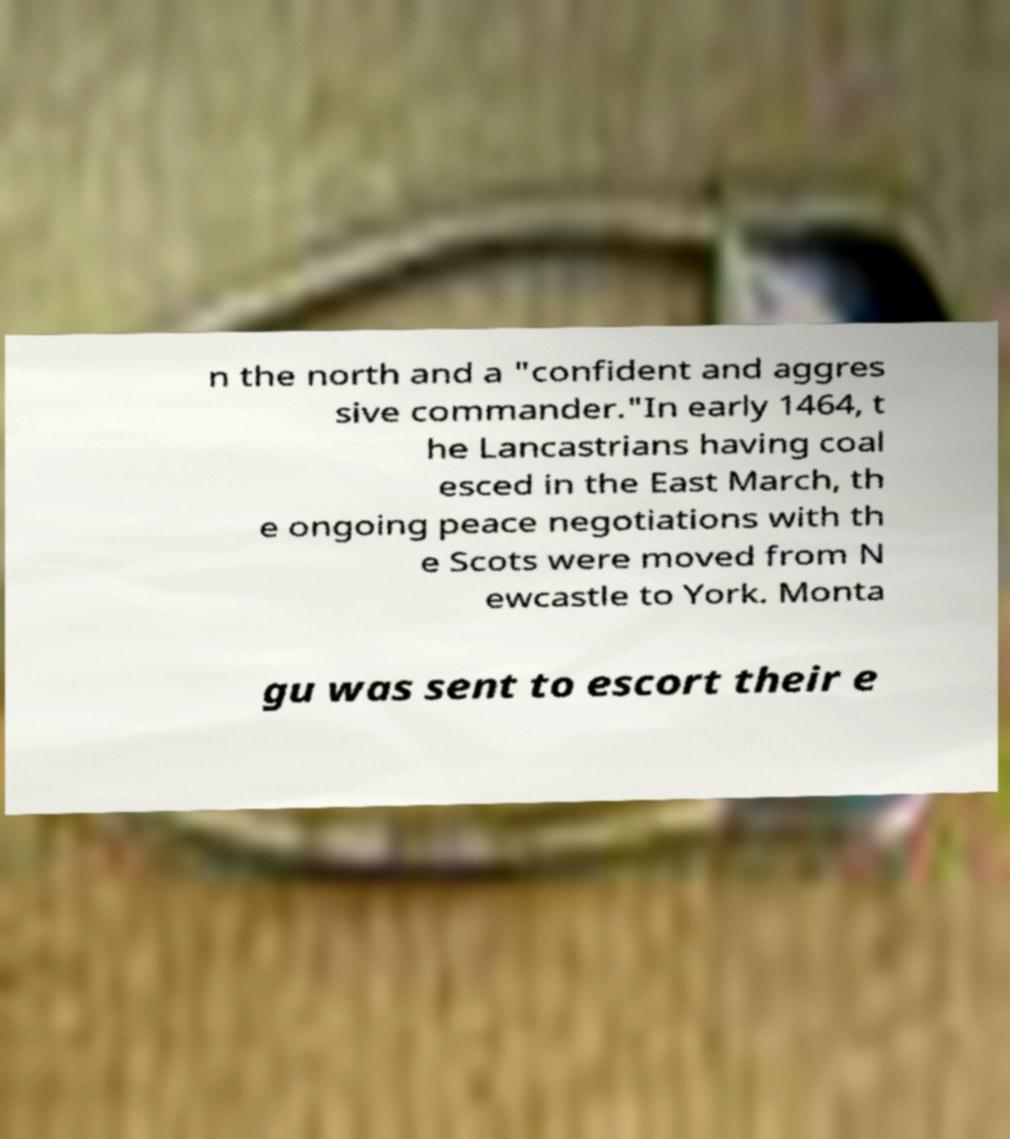I need the written content from this picture converted into text. Can you do that? n the north and a "confident and aggres sive commander."In early 1464, t he Lancastrians having coal esced in the East March, th e ongoing peace negotiations with th e Scots were moved from N ewcastle to York. Monta gu was sent to escort their e 